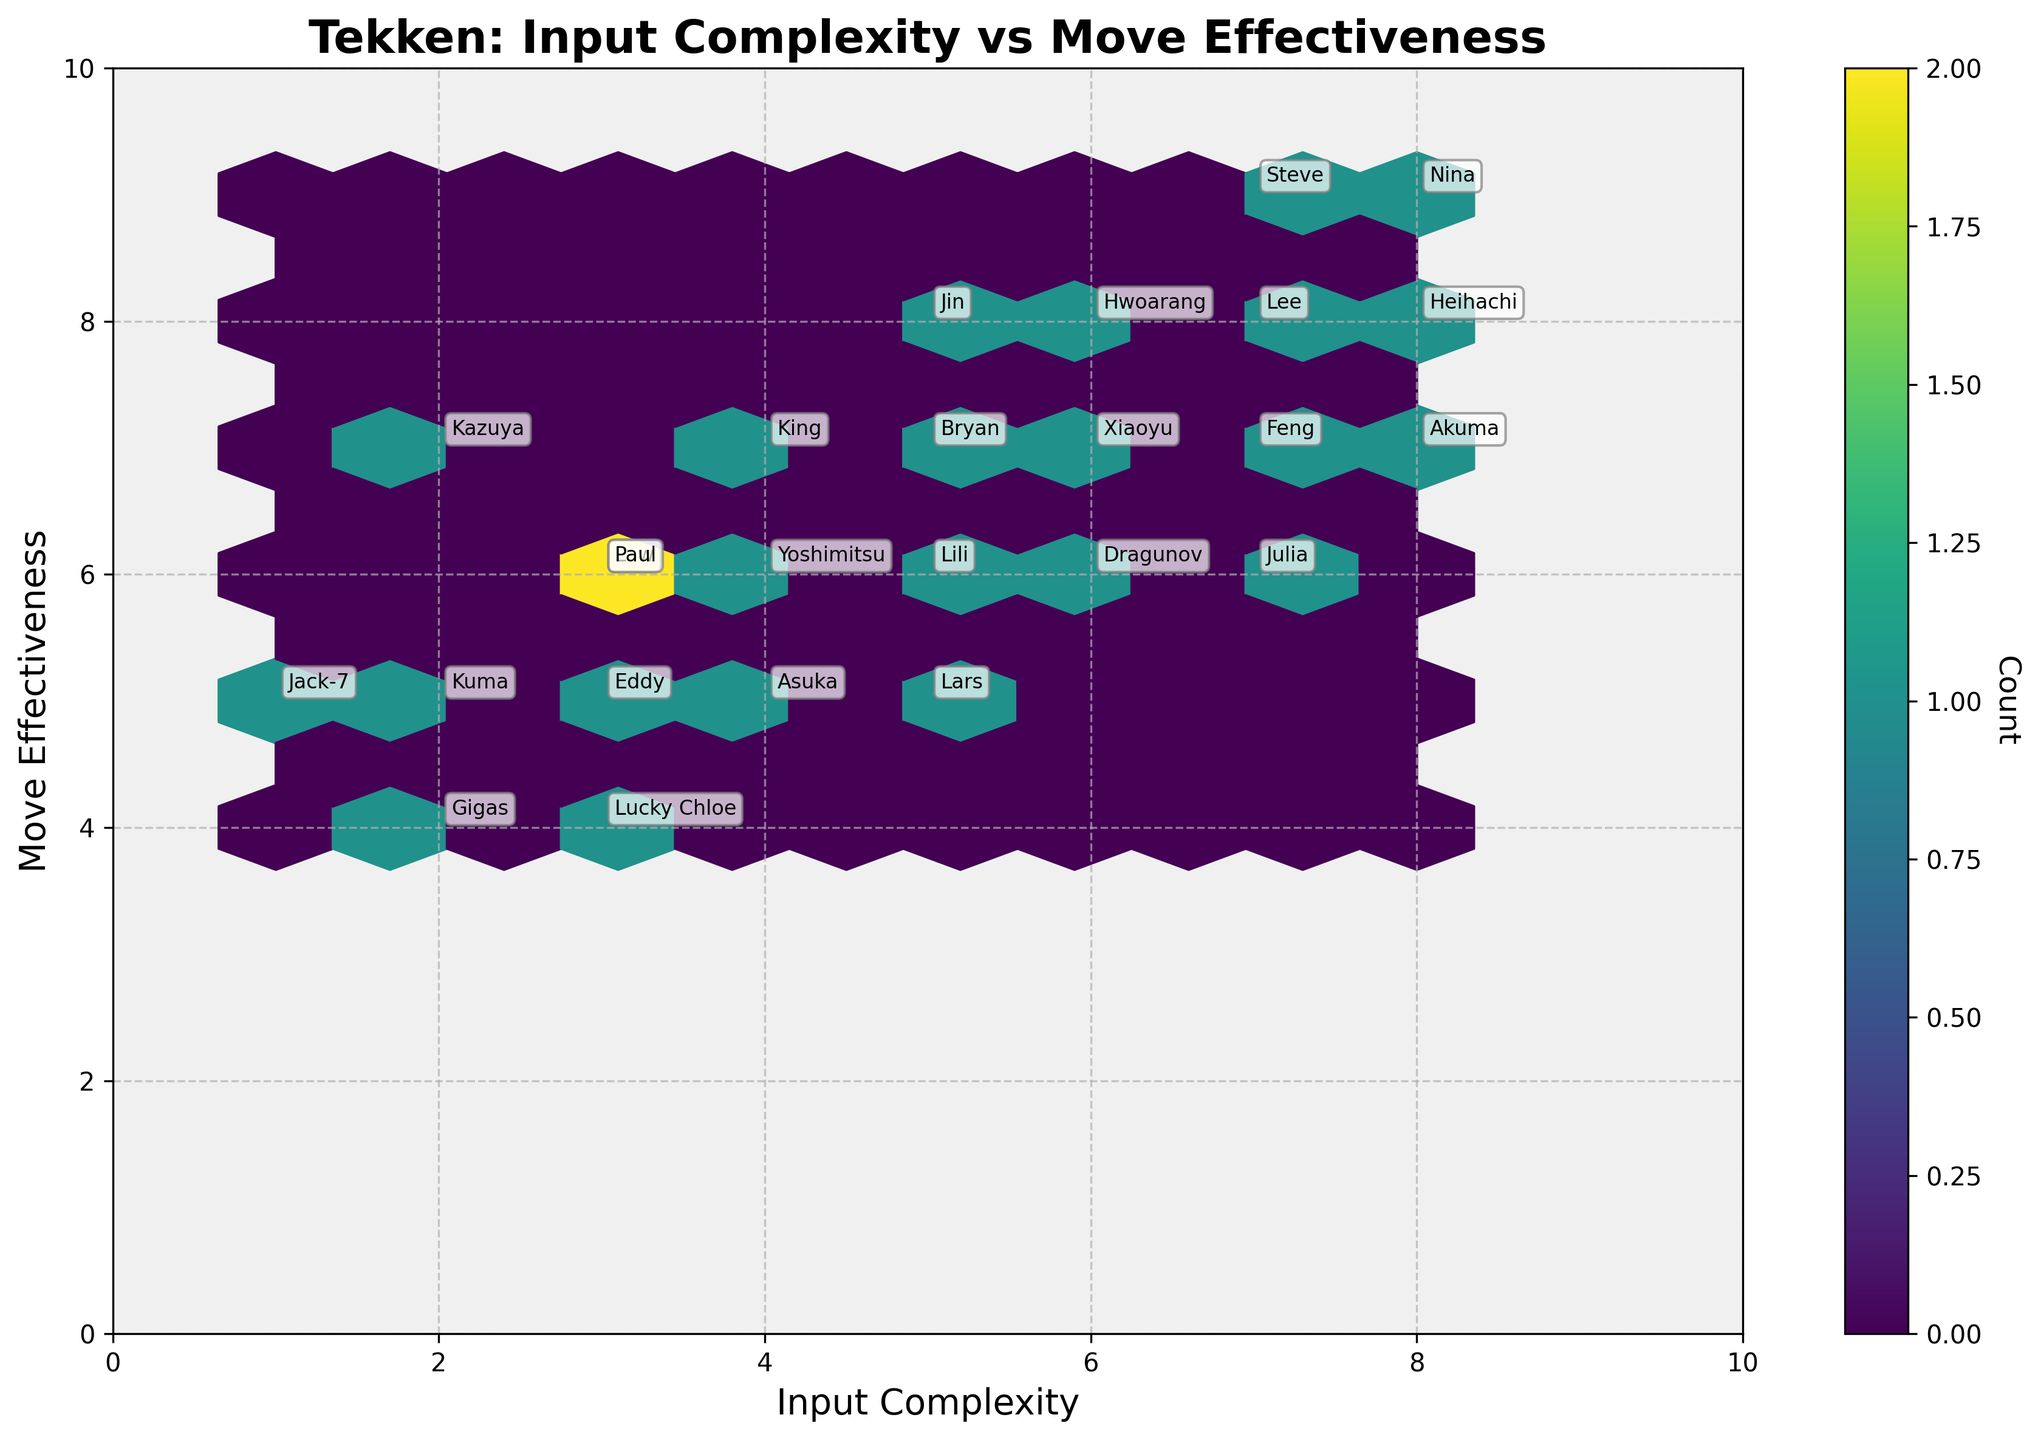What is the title of the plot? The title is placed at the top center of the plot and it gives an overall description of the plot’s content. The title is "Tekken: Input Complexity vs Move Effectiveness."
Answer: Tekken: Input Complexity vs Move Effectiveness How many characters have an input complexity of 7? In the hexbin plot, you can identify data points by counting the characters' annotations. The characters with an input complexity of 7 are Steve, Lee, Feng, and Julia. So, there are 4 characters.
Answer: 4 Which character has the highest move effectiveness and how complex is their input? By looking for the character label at the highest point on the y-axis, we see Nina has the highest move effectiveness of 9. Nina's input complexity is 8.
Answer: Nina, 8 What is the range of move effectiveness values displayed? The range can be calculated by subtracting the lowest value of Move Effectiveness from the highest value seen on the y-axis. The lowest move effectiveness is 4 and the highest is 9.
Answer: 4-9 Which character has both the lowest input complexity and move effectiveness? To find this, we need to locate the data point that is the lowest on both axes. Gigas, with input complexity of 2 and move effectiveness of 4, has the lowest values.
Answer: Gigas How many characters have a move effectiveness of 5? Count the character labels positioned at a move effectiveness value of 5 on the y-axis. Characters at a move effectiveness of 5 are Jack-7, Kuma, Eddy, Asuka, and Lars. So, there are 5 characters.
Answer: 5 Which character has a higher input complexity, King or Law? Compare the input complexity values for both characters, found at their corresponding labels. King has an input complexity of 4 while Law has an input complexity of 3. So, King has a higher input complexity.
Answer: King Is there a character with an input complexity of 6 and a move effectiveness of 8? Identify character labels positioned at an input complexity of 6 on the x-axis and match them to a move effectiveness of 8 on the y-axis. The character with these values is Hwoarang.
Answer: Hwoarang What is the most common move effectiveness value among the characters? Look at where the hexagons are densest in the vertical direction. Move effectiveness value of 5 has the highest count of characters. Therefore, the most common move effectiveness value is 5.
Answer: 5 